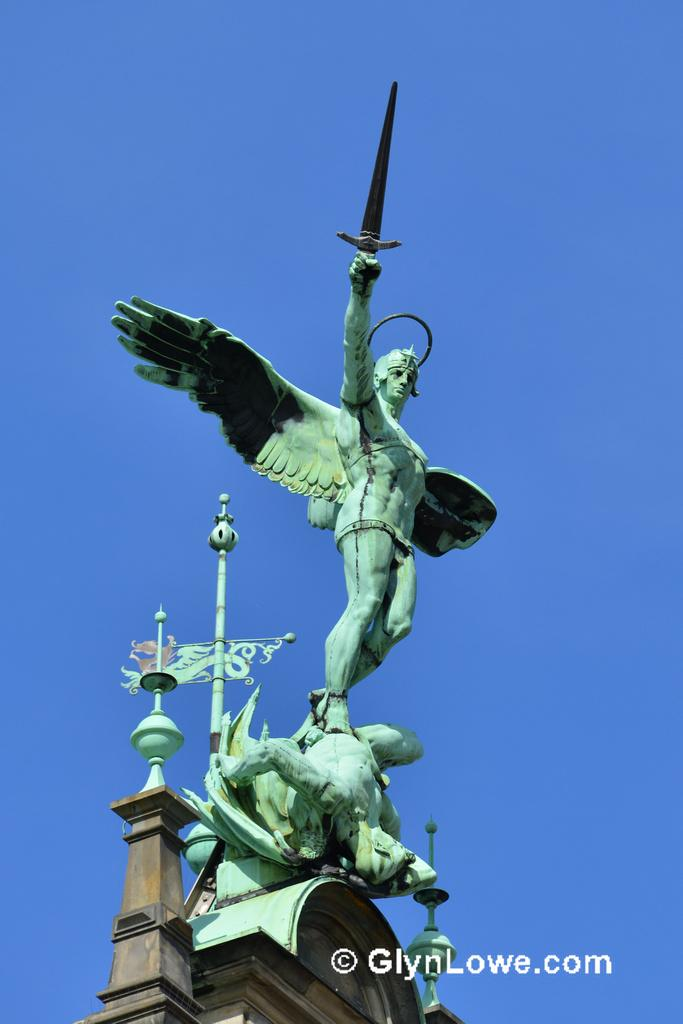What is the main subject in the image? There is a statue in the image. Where is the statue located in relation to other objects? The statue is near a building. What is the color of the statue? The statue is green in color. What is the statue depicting? The statue depicts a person holding a weapon. What can be seen in the background of the image? The sky is blue in the background of the image. What caused the statue's hands to become detached in the image? There is no indication in the image that the statue's hands are detached or damaged in any way. 